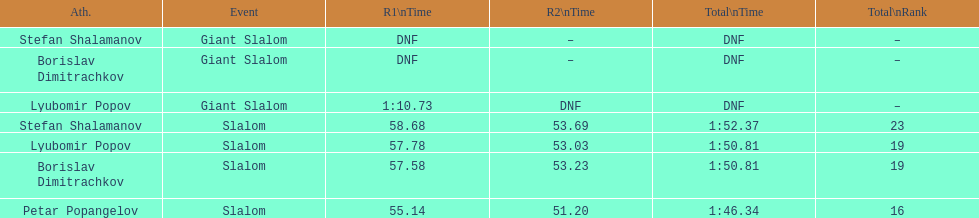Which athlete had a race time above 1:00? Lyubomir Popov. 